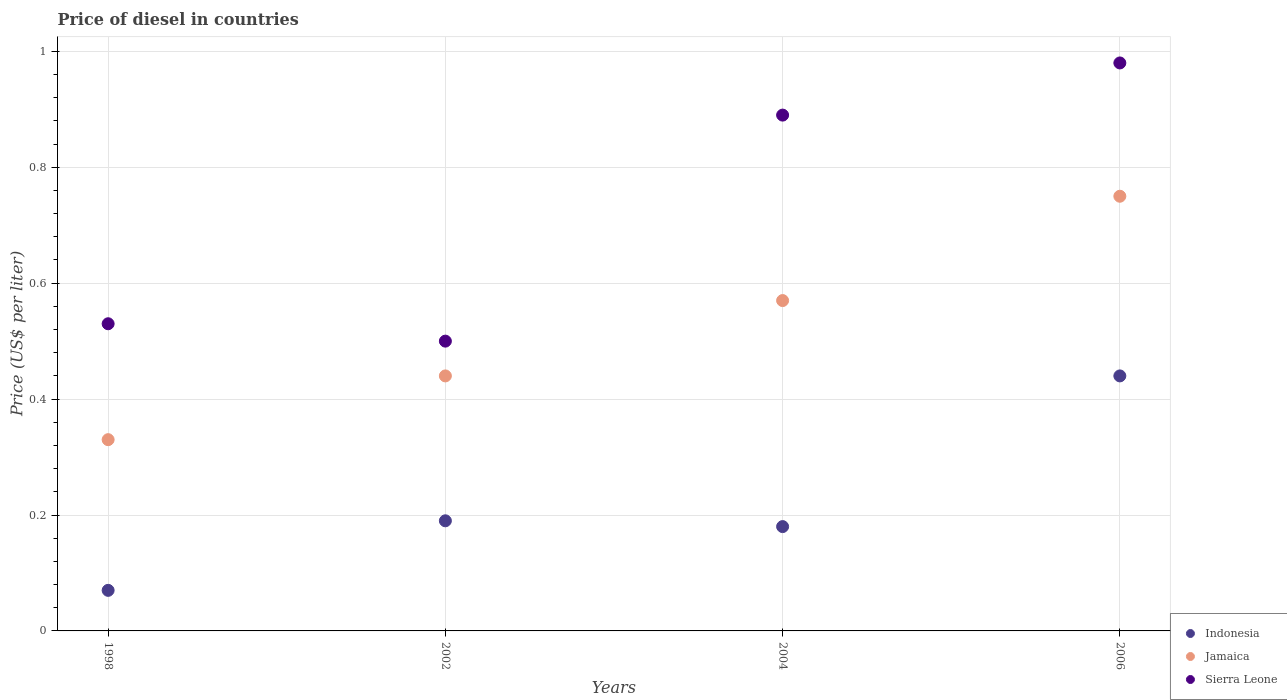What is the price of diesel in Sierra Leone in 1998?
Provide a short and direct response. 0.53. Across all years, what is the minimum price of diesel in Indonesia?
Your answer should be compact. 0.07. In which year was the price of diesel in Jamaica minimum?
Keep it short and to the point. 1998. What is the difference between the price of diesel in Jamaica in 1998 and that in 2004?
Your response must be concise. -0.24. What is the difference between the price of diesel in Sierra Leone in 2006 and the price of diesel in Indonesia in 1998?
Your answer should be very brief. 0.91. What is the average price of diesel in Indonesia per year?
Your answer should be compact. 0.22. In the year 2006, what is the difference between the price of diesel in Jamaica and price of diesel in Sierra Leone?
Provide a short and direct response. -0.23. What is the ratio of the price of diesel in Sierra Leone in 1998 to that in 2004?
Your response must be concise. 0.6. Is the price of diesel in Jamaica in 2002 less than that in 2004?
Keep it short and to the point. Yes. Is the difference between the price of diesel in Jamaica in 2002 and 2006 greater than the difference between the price of diesel in Sierra Leone in 2002 and 2006?
Your answer should be compact. Yes. What is the difference between the highest and the lowest price of diesel in Indonesia?
Offer a very short reply. 0.37. Is it the case that in every year, the sum of the price of diesel in Sierra Leone and price of diesel in Indonesia  is greater than the price of diesel in Jamaica?
Your answer should be very brief. Yes. Does the price of diesel in Sierra Leone monotonically increase over the years?
Make the answer very short. No. Is the price of diesel in Sierra Leone strictly greater than the price of diesel in Jamaica over the years?
Make the answer very short. Yes. How many dotlines are there?
Make the answer very short. 3. How many years are there in the graph?
Keep it short and to the point. 4. Are the values on the major ticks of Y-axis written in scientific E-notation?
Give a very brief answer. No. Where does the legend appear in the graph?
Your answer should be compact. Bottom right. How many legend labels are there?
Keep it short and to the point. 3. What is the title of the graph?
Provide a succinct answer. Price of diesel in countries. What is the label or title of the Y-axis?
Give a very brief answer. Price (US$ per liter). What is the Price (US$ per liter) in Indonesia in 1998?
Your answer should be very brief. 0.07. What is the Price (US$ per liter) of Jamaica in 1998?
Offer a very short reply. 0.33. What is the Price (US$ per liter) in Sierra Leone in 1998?
Make the answer very short. 0.53. What is the Price (US$ per liter) of Indonesia in 2002?
Make the answer very short. 0.19. What is the Price (US$ per liter) in Jamaica in 2002?
Make the answer very short. 0.44. What is the Price (US$ per liter) of Sierra Leone in 2002?
Make the answer very short. 0.5. What is the Price (US$ per liter) of Indonesia in 2004?
Offer a very short reply. 0.18. What is the Price (US$ per liter) in Jamaica in 2004?
Your answer should be very brief. 0.57. What is the Price (US$ per liter) of Sierra Leone in 2004?
Provide a short and direct response. 0.89. What is the Price (US$ per liter) in Indonesia in 2006?
Offer a very short reply. 0.44. Across all years, what is the maximum Price (US$ per liter) of Indonesia?
Keep it short and to the point. 0.44. Across all years, what is the maximum Price (US$ per liter) in Sierra Leone?
Offer a very short reply. 0.98. Across all years, what is the minimum Price (US$ per liter) of Indonesia?
Make the answer very short. 0.07. Across all years, what is the minimum Price (US$ per liter) in Jamaica?
Provide a short and direct response. 0.33. Across all years, what is the minimum Price (US$ per liter) in Sierra Leone?
Provide a succinct answer. 0.5. What is the total Price (US$ per liter) of Indonesia in the graph?
Give a very brief answer. 0.88. What is the total Price (US$ per liter) of Jamaica in the graph?
Provide a short and direct response. 2.09. What is the difference between the Price (US$ per liter) of Indonesia in 1998 and that in 2002?
Provide a short and direct response. -0.12. What is the difference between the Price (US$ per liter) in Jamaica in 1998 and that in 2002?
Your answer should be very brief. -0.11. What is the difference between the Price (US$ per liter) of Indonesia in 1998 and that in 2004?
Offer a terse response. -0.11. What is the difference between the Price (US$ per liter) in Jamaica in 1998 and that in 2004?
Offer a very short reply. -0.24. What is the difference between the Price (US$ per liter) in Sierra Leone in 1998 and that in 2004?
Offer a very short reply. -0.36. What is the difference between the Price (US$ per liter) of Indonesia in 1998 and that in 2006?
Provide a short and direct response. -0.37. What is the difference between the Price (US$ per liter) in Jamaica in 1998 and that in 2006?
Your answer should be very brief. -0.42. What is the difference between the Price (US$ per liter) in Sierra Leone in 1998 and that in 2006?
Your answer should be very brief. -0.45. What is the difference between the Price (US$ per liter) of Jamaica in 2002 and that in 2004?
Provide a short and direct response. -0.13. What is the difference between the Price (US$ per liter) in Sierra Leone in 2002 and that in 2004?
Your answer should be very brief. -0.39. What is the difference between the Price (US$ per liter) in Jamaica in 2002 and that in 2006?
Provide a short and direct response. -0.31. What is the difference between the Price (US$ per liter) of Sierra Leone in 2002 and that in 2006?
Your answer should be compact. -0.48. What is the difference between the Price (US$ per liter) in Indonesia in 2004 and that in 2006?
Provide a succinct answer. -0.26. What is the difference between the Price (US$ per liter) of Jamaica in 2004 and that in 2006?
Offer a very short reply. -0.18. What is the difference between the Price (US$ per liter) of Sierra Leone in 2004 and that in 2006?
Your answer should be very brief. -0.09. What is the difference between the Price (US$ per liter) in Indonesia in 1998 and the Price (US$ per liter) in Jamaica in 2002?
Give a very brief answer. -0.37. What is the difference between the Price (US$ per liter) in Indonesia in 1998 and the Price (US$ per liter) in Sierra Leone in 2002?
Provide a short and direct response. -0.43. What is the difference between the Price (US$ per liter) of Jamaica in 1998 and the Price (US$ per liter) of Sierra Leone in 2002?
Offer a very short reply. -0.17. What is the difference between the Price (US$ per liter) of Indonesia in 1998 and the Price (US$ per liter) of Jamaica in 2004?
Provide a short and direct response. -0.5. What is the difference between the Price (US$ per liter) of Indonesia in 1998 and the Price (US$ per liter) of Sierra Leone in 2004?
Your response must be concise. -0.82. What is the difference between the Price (US$ per liter) in Jamaica in 1998 and the Price (US$ per liter) in Sierra Leone in 2004?
Offer a terse response. -0.56. What is the difference between the Price (US$ per liter) of Indonesia in 1998 and the Price (US$ per liter) of Jamaica in 2006?
Make the answer very short. -0.68. What is the difference between the Price (US$ per liter) of Indonesia in 1998 and the Price (US$ per liter) of Sierra Leone in 2006?
Offer a terse response. -0.91. What is the difference between the Price (US$ per liter) of Jamaica in 1998 and the Price (US$ per liter) of Sierra Leone in 2006?
Provide a short and direct response. -0.65. What is the difference between the Price (US$ per liter) of Indonesia in 2002 and the Price (US$ per liter) of Jamaica in 2004?
Give a very brief answer. -0.38. What is the difference between the Price (US$ per liter) in Indonesia in 2002 and the Price (US$ per liter) in Sierra Leone in 2004?
Keep it short and to the point. -0.7. What is the difference between the Price (US$ per liter) of Jamaica in 2002 and the Price (US$ per liter) of Sierra Leone in 2004?
Offer a very short reply. -0.45. What is the difference between the Price (US$ per liter) in Indonesia in 2002 and the Price (US$ per liter) in Jamaica in 2006?
Offer a very short reply. -0.56. What is the difference between the Price (US$ per liter) in Indonesia in 2002 and the Price (US$ per liter) in Sierra Leone in 2006?
Provide a short and direct response. -0.79. What is the difference between the Price (US$ per liter) in Jamaica in 2002 and the Price (US$ per liter) in Sierra Leone in 2006?
Make the answer very short. -0.54. What is the difference between the Price (US$ per liter) of Indonesia in 2004 and the Price (US$ per liter) of Jamaica in 2006?
Offer a very short reply. -0.57. What is the difference between the Price (US$ per liter) in Indonesia in 2004 and the Price (US$ per liter) in Sierra Leone in 2006?
Make the answer very short. -0.8. What is the difference between the Price (US$ per liter) in Jamaica in 2004 and the Price (US$ per liter) in Sierra Leone in 2006?
Your answer should be very brief. -0.41. What is the average Price (US$ per liter) in Indonesia per year?
Provide a succinct answer. 0.22. What is the average Price (US$ per liter) of Jamaica per year?
Offer a very short reply. 0.52. What is the average Price (US$ per liter) in Sierra Leone per year?
Ensure brevity in your answer.  0.72. In the year 1998, what is the difference between the Price (US$ per liter) in Indonesia and Price (US$ per liter) in Jamaica?
Your answer should be compact. -0.26. In the year 1998, what is the difference between the Price (US$ per liter) of Indonesia and Price (US$ per liter) of Sierra Leone?
Provide a succinct answer. -0.46. In the year 1998, what is the difference between the Price (US$ per liter) in Jamaica and Price (US$ per liter) in Sierra Leone?
Provide a succinct answer. -0.2. In the year 2002, what is the difference between the Price (US$ per liter) in Indonesia and Price (US$ per liter) in Sierra Leone?
Your answer should be compact. -0.31. In the year 2002, what is the difference between the Price (US$ per liter) in Jamaica and Price (US$ per liter) in Sierra Leone?
Your response must be concise. -0.06. In the year 2004, what is the difference between the Price (US$ per liter) in Indonesia and Price (US$ per liter) in Jamaica?
Provide a succinct answer. -0.39. In the year 2004, what is the difference between the Price (US$ per liter) in Indonesia and Price (US$ per liter) in Sierra Leone?
Keep it short and to the point. -0.71. In the year 2004, what is the difference between the Price (US$ per liter) in Jamaica and Price (US$ per liter) in Sierra Leone?
Offer a very short reply. -0.32. In the year 2006, what is the difference between the Price (US$ per liter) of Indonesia and Price (US$ per liter) of Jamaica?
Your response must be concise. -0.31. In the year 2006, what is the difference between the Price (US$ per liter) in Indonesia and Price (US$ per liter) in Sierra Leone?
Ensure brevity in your answer.  -0.54. In the year 2006, what is the difference between the Price (US$ per liter) in Jamaica and Price (US$ per liter) in Sierra Leone?
Your answer should be very brief. -0.23. What is the ratio of the Price (US$ per liter) in Indonesia in 1998 to that in 2002?
Your answer should be very brief. 0.37. What is the ratio of the Price (US$ per liter) of Sierra Leone in 1998 to that in 2002?
Ensure brevity in your answer.  1.06. What is the ratio of the Price (US$ per liter) of Indonesia in 1998 to that in 2004?
Provide a short and direct response. 0.39. What is the ratio of the Price (US$ per liter) in Jamaica in 1998 to that in 2004?
Your answer should be very brief. 0.58. What is the ratio of the Price (US$ per liter) of Sierra Leone in 1998 to that in 2004?
Keep it short and to the point. 0.6. What is the ratio of the Price (US$ per liter) of Indonesia in 1998 to that in 2006?
Your answer should be very brief. 0.16. What is the ratio of the Price (US$ per liter) in Jamaica in 1998 to that in 2006?
Give a very brief answer. 0.44. What is the ratio of the Price (US$ per liter) in Sierra Leone in 1998 to that in 2006?
Your answer should be compact. 0.54. What is the ratio of the Price (US$ per liter) in Indonesia in 2002 to that in 2004?
Ensure brevity in your answer.  1.06. What is the ratio of the Price (US$ per liter) of Jamaica in 2002 to that in 2004?
Ensure brevity in your answer.  0.77. What is the ratio of the Price (US$ per liter) of Sierra Leone in 2002 to that in 2004?
Offer a terse response. 0.56. What is the ratio of the Price (US$ per liter) of Indonesia in 2002 to that in 2006?
Your response must be concise. 0.43. What is the ratio of the Price (US$ per liter) of Jamaica in 2002 to that in 2006?
Offer a very short reply. 0.59. What is the ratio of the Price (US$ per liter) in Sierra Leone in 2002 to that in 2006?
Make the answer very short. 0.51. What is the ratio of the Price (US$ per liter) of Indonesia in 2004 to that in 2006?
Keep it short and to the point. 0.41. What is the ratio of the Price (US$ per liter) in Jamaica in 2004 to that in 2006?
Your response must be concise. 0.76. What is the ratio of the Price (US$ per liter) in Sierra Leone in 2004 to that in 2006?
Keep it short and to the point. 0.91. What is the difference between the highest and the second highest Price (US$ per liter) in Indonesia?
Keep it short and to the point. 0.25. What is the difference between the highest and the second highest Price (US$ per liter) in Jamaica?
Provide a short and direct response. 0.18. What is the difference between the highest and the second highest Price (US$ per liter) of Sierra Leone?
Your response must be concise. 0.09. What is the difference between the highest and the lowest Price (US$ per liter) in Indonesia?
Offer a terse response. 0.37. What is the difference between the highest and the lowest Price (US$ per liter) of Jamaica?
Provide a short and direct response. 0.42. What is the difference between the highest and the lowest Price (US$ per liter) in Sierra Leone?
Make the answer very short. 0.48. 